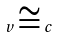<formula> <loc_0><loc_0><loc_500><loc_500>v \cong c</formula> 